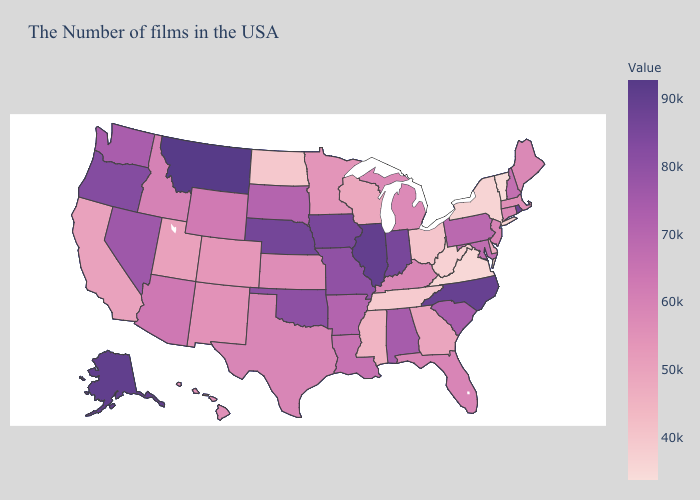Which states have the lowest value in the USA?
Write a very short answer. Vermont. Which states have the lowest value in the South?
Answer briefly. Virginia. Does Montana have the highest value in the USA?
Keep it brief. Yes. Among the states that border Mississippi , does Tennessee have the lowest value?
Write a very short answer. Yes. Which states have the lowest value in the South?
Give a very brief answer. Virginia. Which states have the highest value in the USA?
Short answer required. Montana. 